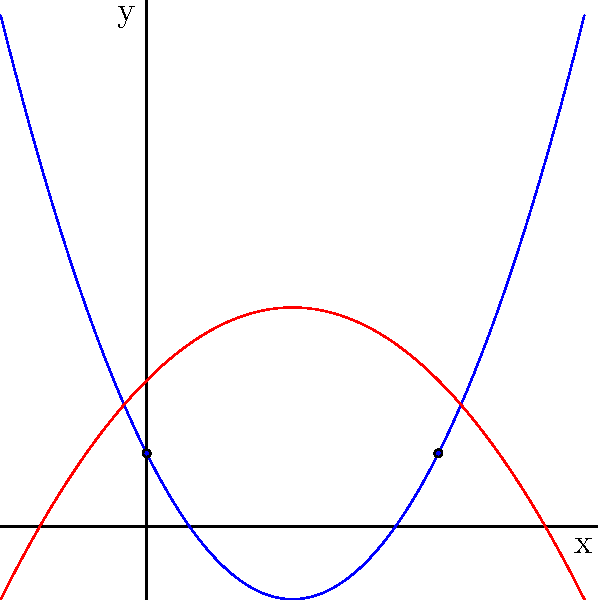As an office manager, you're analyzing the company's profit trends. Two different product lines are represented by quadratic functions:

$f(x) = 0.5x^2 - 2x + 1$ (blue curve)
$g(x) = -0.25x^2 + x + 2$ (red curve)

Where $x$ represents months since the product launch, and $y$ represents profit in thousands of lei.

How many months after the launch do the profit curves intersect? To find the intersection points, we need to solve the equation:

$f(x) = g(x)$

$0.5x^2 - 2x + 1 = -0.25x^2 + x + 2$

Rearranging the terms:

$0.5x^2 + 0.25x^2 - 2x - x + 1 - 2 = 0$

$0.75x^2 - 3x - 1 = 0$

Multiplying all terms by 4 to simplify:

$3x^2 - 12x - 4 = 0$

This is a quadratic equation in the form $ax^2 + bx + c = 0$, where:
$a = 3$, $b = -12$, and $c = -4$

We can solve this using the quadratic formula: $x = \frac{-b \pm \sqrt{b^2 - 4ac}}{2a}$

$x = \frac{12 \pm \sqrt{(-12)^2 - 4(3)(-4)}}{2(3)}$

$x = \frac{12 \pm \sqrt{144 + 48}}{6} = \frac{12 \pm \sqrt{192}}{6} = \frac{12 \pm 4\sqrt{12}}{6}$

$x = 2 \pm \frac{2\sqrt{12}}{3}$

This gives us two solutions:

$x_1 = 2 + \frac{2\sqrt{12}}{3} \approx 4$ (months)
$x_2 = 2 - \frac{2\sqrt{12}}{3} \approx 0$ (months)

The curves intersect at two points: immediately at launch (0 months) and after 4 months.
Answer: 4 months 